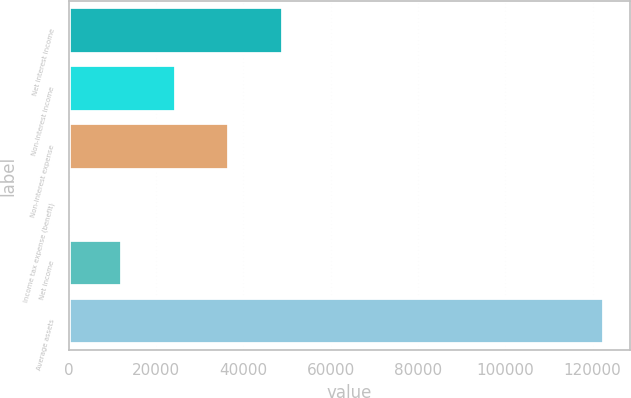Convert chart. <chart><loc_0><loc_0><loc_500><loc_500><bar_chart><fcel>Net interest income<fcel>Non-interest income<fcel>Non-interest expense<fcel>Income tax expense (benefit)<fcel>Net income<fcel>Average assets<nl><fcel>49030<fcel>24541<fcel>36785.5<fcel>52<fcel>12296.5<fcel>122497<nl></chart> 